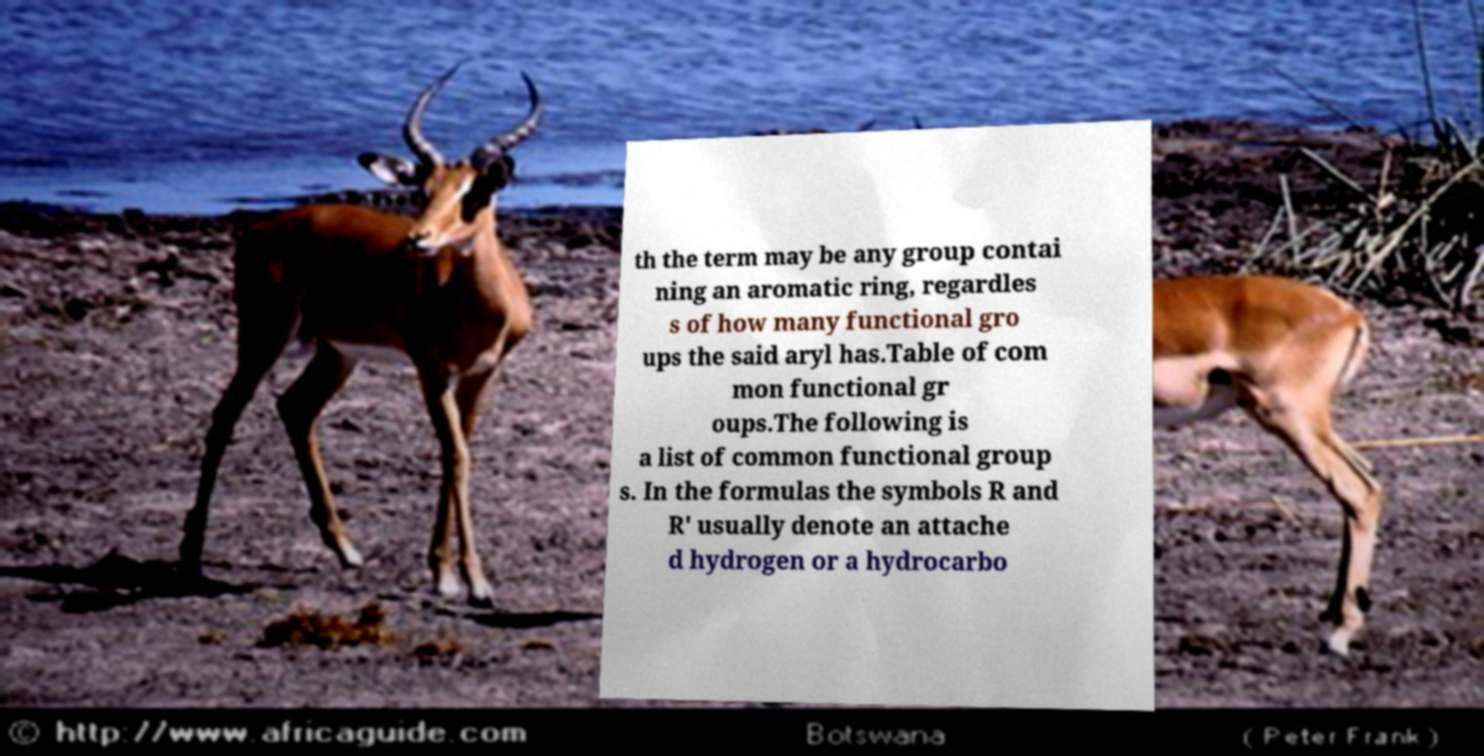I need the written content from this picture converted into text. Can you do that? th the term may be any group contai ning an aromatic ring, regardles s of how many functional gro ups the said aryl has.Table of com mon functional gr oups.The following is a list of common functional group s. In the formulas the symbols R and R' usually denote an attache d hydrogen or a hydrocarbo 